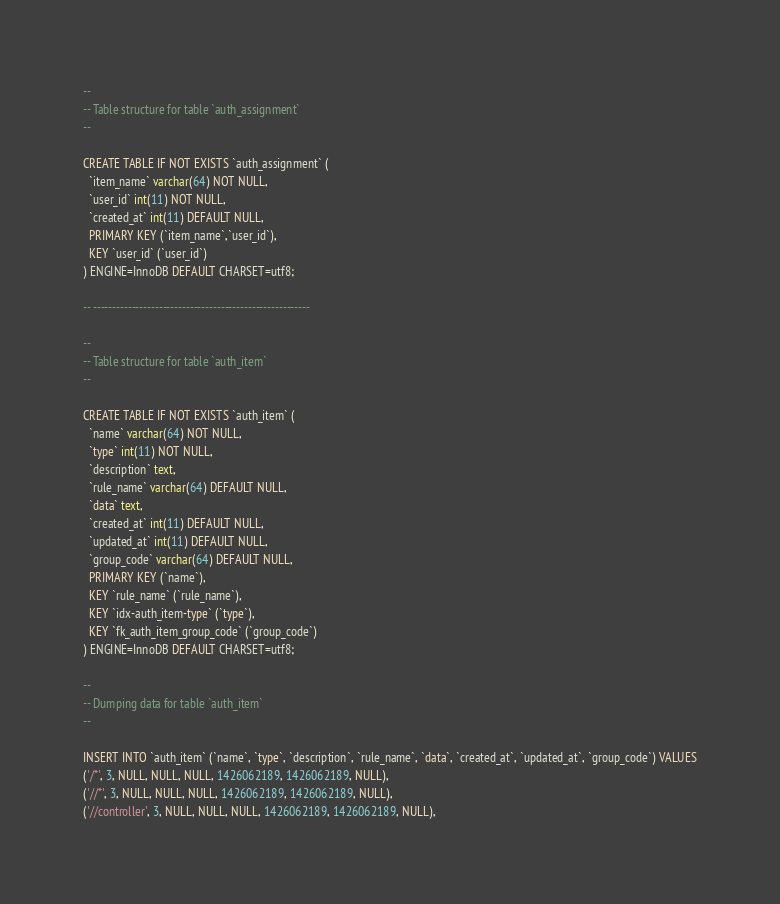<code> <loc_0><loc_0><loc_500><loc_500><_SQL_>
--
-- Table structure for table `auth_assignment`
--

CREATE TABLE IF NOT EXISTS `auth_assignment` (
  `item_name` varchar(64) NOT NULL,
  `user_id` int(11) NOT NULL,
  `created_at` int(11) DEFAULT NULL,
  PRIMARY KEY (`item_name`,`user_id`),
  KEY `user_id` (`user_id`)
) ENGINE=InnoDB DEFAULT CHARSET=utf8;

-- --------------------------------------------------------

--
-- Table structure for table `auth_item`
--

CREATE TABLE IF NOT EXISTS `auth_item` (
  `name` varchar(64) NOT NULL,
  `type` int(11) NOT NULL,
  `description` text,
  `rule_name` varchar(64) DEFAULT NULL,
  `data` text,
  `created_at` int(11) DEFAULT NULL,
  `updated_at` int(11) DEFAULT NULL,
  `group_code` varchar(64) DEFAULT NULL,
  PRIMARY KEY (`name`),
  KEY `rule_name` (`rule_name`),
  KEY `idx-auth_item-type` (`type`),
  KEY `fk_auth_item_group_code` (`group_code`)
) ENGINE=InnoDB DEFAULT CHARSET=utf8;

--
-- Dumping data for table `auth_item`
--

INSERT INTO `auth_item` (`name`, `type`, `description`, `rule_name`, `data`, `created_at`, `updated_at`, `group_code`) VALUES
('/*', 3, NULL, NULL, NULL, 1426062189, 1426062189, NULL),
('//*', 3, NULL, NULL, NULL, 1426062189, 1426062189, NULL),
('//controller', 3, NULL, NULL, NULL, 1426062189, 1426062189, NULL),</code> 